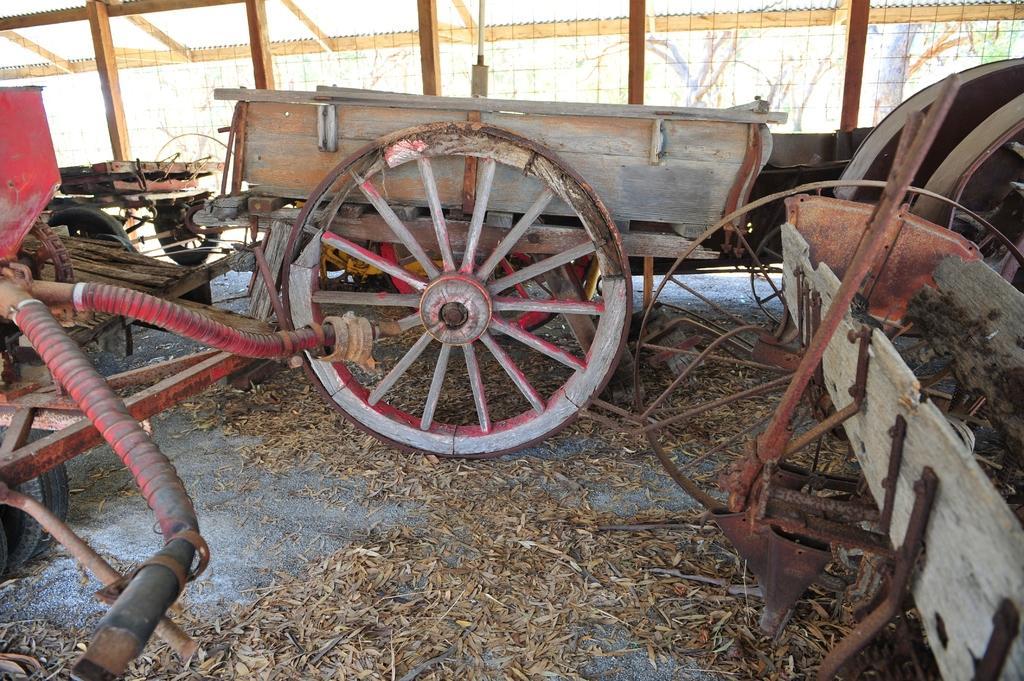In one or two sentences, can you explain what this image depicts? In this image I can see few carts, wooden logs, leaves and few objects. 